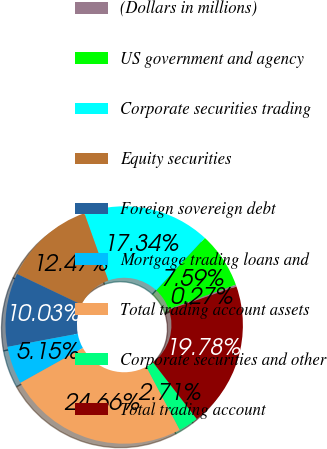Convert chart. <chart><loc_0><loc_0><loc_500><loc_500><pie_chart><fcel>(Dollars in millions)<fcel>US government and agency<fcel>Corporate securities trading<fcel>Equity securities<fcel>Foreign sovereign debt<fcel>Mortgage trading loans and<fcel>Total trading account assets<fcel>Corporate securities and other<fcel>Total trading account<nl><fcel>0.27%<fcel>7.59%<fcel>17.34%<fcel>12.47%<fcel>10.03%<fcel>5.15%<fcel>24.66%<fcel>2.71%<fcel>19.78%<nl></chart> 